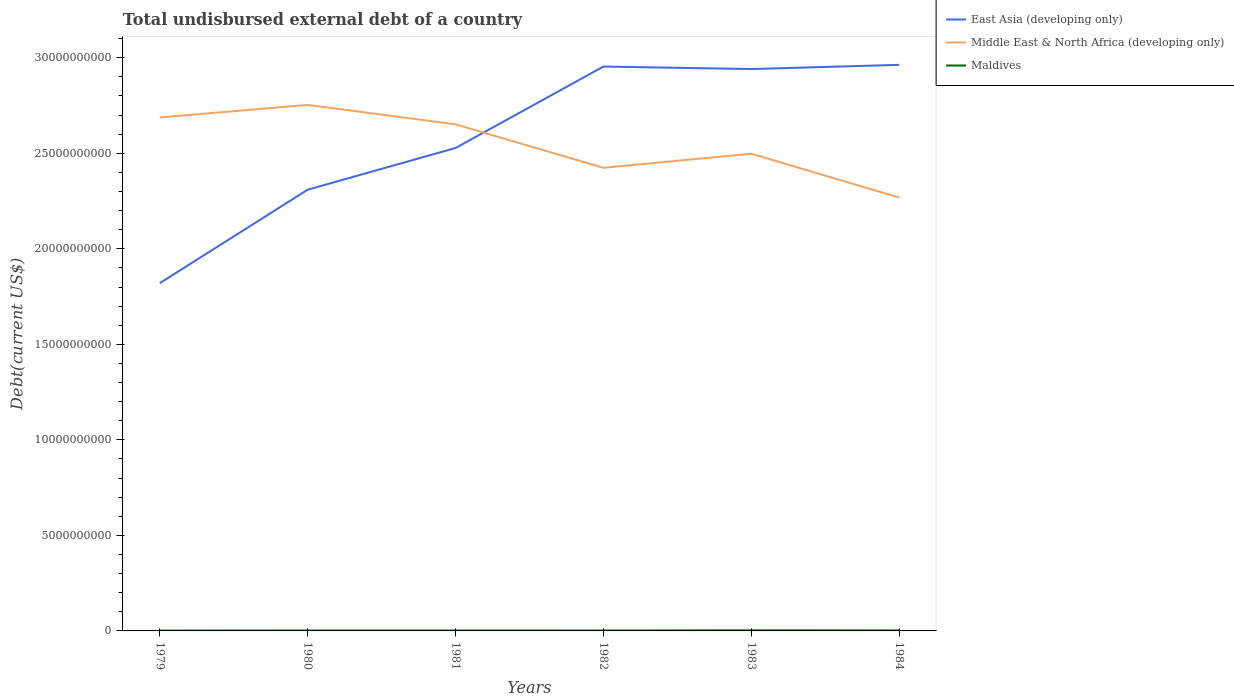Does the line corresponding to East Asia (developing only) intersect with the line corresponding to Middle East & North Africa (developing only)?
Your answer should be compact. Yes. Across all years, what is the maximum total undisbursed external debt in Maldives?
Provide a succinct answer. 1.66e+07. In which year was the total undisbursed external debt in East Asia (developing only) maximum?
Your answer should be very brief. 1979. What is the total total undisbursed external debt in Middle East & North Africa (developing only) in the graph?
Ensure brevity in your answer.  4.85e+09. What is the difference between the highest and the second highest total undisbursed external debt in Maldives?
Offer a terse response. 1.24e+07. Is the total undisbursed external debt in Maldives strictly greater than the total undisbursed external debt in East Asia (developing only) over the years?
Give a very brief answer. Yes. How many lines are there?
Make the answer very short. 3. How many years are there in the graph?
Provide a succinct answer. 6. What is the difference between two consecutive major ticks on the Y-axis?
Provide a short and direct response. 5.00e+09. Where does the legend appear in the graph?
Your answer should be compact. Top right. What is the title of the graph?
Offer a terse response. Total undisbursed external debt of a country. What is the label or title of the X-axis?
Keep it short and to the point. Years. What is the label or title of the Y-axis?
Make the answer very short. Debt(current US$). What is the Debt(current US$) in East Asia (developing only) in 1979?
Ensure brevity in your answer.  1.82e+1. What is the Debt(current US$) of Middle East & North Africa (developing only) in 1979?
Ensure brevity in your answer.  2.69e+1. What is the Debt(current US$) in Maldives in 1979?
Provide a succinct answer. 1.66e+07. What is the Debt(current US$) of East Asia (developing only) in 1980?
Keep it short and to the point. 2.31e+1. What is the Debt(current US$) of Middle East & North Africa (developing only) in 1980?
Provide a succinct answer. 2.75e+1. What is the Debt(current US$) of Maldives in 1980?
Your answer should be compact. 2.10e+07. What is the Debt(current US$) of East Asia (developing only) in 1981?
Your answer should be compact. 2.53e+1. What is the Debt(current US$) of Middle East & North Africa (developing only) in 1981?
Offer a terse response. 2.65e+1. What is the Debt(current US$) of Maldives in 1981?
Ensure brevity in your answer.  2.11e+07. What is the Debt(current US$) in East Asia (developing only) in 1982?
Provide a short and direct response. 2.95e+1. What is the Debt(current US$) in Middle East & North Africa (developing only) in 1982?
Offer a terse response. 2.42e+1. What is the Debt(current US$) of Maldives in 1982?
Keep it short and to the point. 1.96e+07. What is the Debt(current US$) of East Asia (developing only) in 1983?
Your answer should be compact. 2.94e+1. What is the Debt(current US$) of Middle East & North Africa (developing only) in 1983?
Keep it short and to the point. 2.50e+1. What is the Debt(current US$) in Maldives in 1983?
Your response must be concise. 2.91e+07. What is the Debt(current US$) in East Asia (developing only) in 1984?
Keep it short and to the point. 2.96e+1. What is the Debt(current US$) in Middle East & North Africa (developing only) in 1984?
Make the answer very short. 2.27e+1. What is the Debt(current US$) of Maldives in 1984?
Offer a terse response. 2.37e+07. Across all years, what is the maximum Debt(current US$) in East Asia (developing only)?
Offer a very short reply. 2.96e+1. Across all years, what is the maximum Debt(current US$) in Middle East & North Africa (developing only)?
Provide a short and direct response. 2.75e+1. Across all years, what is the maximum Debt(current US$) of Maldives?
Keep it short and to the point. 2.91e+07. Across all years, what is the minimum Debt(current US$) of East Asia (developing only)?
Offer a very short reply. 1.82e+1. Across all years, what is the minimum Debt(current US$) in Middle East & North Africa (developing only)?
Your answer should be very brief. 2.27e+1. Across all years, what is the minimum Debt(current US$) in Maldives?
Provide a succinct answer. 1.66e+07. What is the total Debt(current US$) in East Asia (developing only) in the graph?
Provide a short and direct response. 1.55e+11. What is the total Debt(current US$) in Middle East & North Africa (developing only) in the graph?
Make the answer very short. 1.53e+11. What is the total Debt(current US$) of Maldives in the graph?
Provide a short and direct response. 1.31e+08. What is the difference between the Debt(current US$) of East Asia (developing only) in 1979 and that in 1980?
Make the answer very short. -4.89e+09. What is the difference between the Debt(current US$) in Middle East & North Africa (developing only) in 1979 and that in 1980?
Give a very brief answer. -6.59e+08. What is the difference between the Debt(current US$) in Maldives in 1979 and that in 1980?
Keep it short and to the point. -4.34e+06. What is the difference between the Debt(current US$) in East Asia (developing only) in 1979 and that in 1981?
Your answer should be compact. -7.07e+09. What is the difference between the Debt(current US$) of Middle East & North Africa (developing only) in 1979 and that in 1981?
Keep it short and to the point. 3.59e+08. What is the difference between the Debt(current US$) of Maldives in 1979 and that in 1981?
Your answer should be compact. -4.47e+06. What is the difference between the Debt(current US$) in East Asia (developing only) in 1979 and that in 1982?
Your answer should be compact. -1.13e+1. What is the difference between the Debt(current US$) of Middle East & North Africa (developing only) in 1979 and that in 1982?
Keep it short and to the point. 2.63e+09. What is the difference between the Debt(current US$) of Maldives in 1979 and that in 1982?
Give a very brief answer. -2.97e+06. What is the difference between the Debt(current US$) in East Asia (developing only) in 1979 and that in 1983?
Your answer should be compact. -1.12e+1. What is the difference between the Debt(current US$) of Middle East & North Africa (developing only) in 1979 and that in 1983?
Provide a short and direct response. 1.90e+09. What is the difference between the Debt(current US$) in Maldives in 1979 and that in 1983?
Provide a succinct answer. -1.24e+07. What is the difference between the Debt(current US$) of East Asia (developing only) in 1979 and that in 1984?
Your answer should be very brief. -1.14e+1. What is the difference between the Debt(current US$) of Middle East & North Africa (developing only) in 1979 and that in 1984?
Provide a short and direct response. 4.19e+09. What is the difference between the Debt(current US$) of Maldives in 1979 and that in 1984?
Provide a short and direct response. -7.08e+06. What is the difference between the Debt(current US$) of East Asia (developing only) in 1980 and that in 1981?
Provide a short and direct response. -2.18e+09. What is the difference between the Debt(current US$) in Middle East & North Africa (developing only) in 1980 and that in 1981?
Your answer should be very brief. 1.02e+09. What is the difference between the Debt(current US$) in East Asia (developing only) in 1980 and that in 1982?
Provide a succinct answer. -6.45e+09. What is the difference between the Debt(current US$) in Middle East & North Africa (developing only) in 1980 and that in 1982?
Ensure brevity in your answer.  3.29e+09. What is the difference between the Debt(current US$) in Maldives in 1980 and that in 1982?
Your response must be concise. 1.37e+06. What is the difference between the Debt(current US$) in East Asia (developing only) in 1980 and that in 1983?
Ensure brevity in your answer.  -6.32e+09. What is the difference between the Debt(current US$) of Middle East & North Africa (developing only) in 1980 and that in 1983?
Offer a very short reply. 2.56e+09. What is the difference between the Debt(current US$) in Maldives in 1980 and that in 1983?
Provide a short and direct response. -8.08e+06. What is the difference between the Debt(current US$) in East Asia (developing only) in 1980 and that in 1984?
Provide a short and direct response. -6.53e+09. What is the difference between the Debt(current US$) of Middle East & North Africa (developing only) in 1980 and that in 1984?
Provide a short and direct response. 4.85e+09. What is the difference between the Debt(current US$) in Maldives in 1980 and that in 1984?
Offer a terse response. -2.74e+06. What is the difference between the Debt(current US$) of East Asia (developing only) in 1981 and that in 1982?
Give a very brief answer. -4.26e+09. What is the difference between the Debt(current US$) of Middle East & North Africa (developing only) in 1981 and that in 1982?
Offer a terse response. 2.28e+09. What is the difference between the Debt(current US$) in Maldives in 1981 and that in 1982?
Your answer should be very brief. 1.50e+06. What is the difference between the Debt(current US$) of East Asia (developing only) in 1981 and that in 1983?
Your answer should be compact. -4.13e+09. What is the difference between the Debt(current US$) of Middle East & North Africa (developing only) in 1981 and that in 1983?
Offer a very short reply. 1.54e+09. What is the difference between the Debt(current US$) of Maldives in 1981 and that in 1983?
Your answer should be compact. -7.95e+06. What is the difference between the Debt(current US$) of East Asia (developing only) in 1981 and that in 1984?
Offer a very short reply. -4.35e+09. What is the difference between the Debt(current US$) in Middle East & North Africa (developing only) in 1981 and that in 1984?
Make the answer very short. 3.83e+09. What is the difference between the Debt(current US$) of Maldives in 1981 and that in 1984?
Give a very brief answer. -2.61e+06. What is the difference between the Debt(current US$) in East Asia (developing only) in 1982 and that in 1983?
Your answer should be very brief. 1.31e+08. What is the difference between the Debt(current US$) of Middle East & North Africa (developing only) in 1982 and that in 1983?
Provide a succinct answer. -7.38e+08. What is the difference between the Debt(current US$) of Maldives in 1982 and that in 1983?
Offer a very short reply. -9.46e+06. What is the difference between the Debt(current US$) in East Asia (developing only) in 1982 and that in 1984?
Your response must be concise. -8.84e+07. What is the difference between the Debt(current US$) in Middle East & North Africa (developing only) in 1982 and that in 1984?
Your answer should be compact. 1.56e+09. What is the difference between the Debt(current US$) in Maldives in 1982 and that in 1984?
Your response must be concise. -4.11e+06. What is the difference between the Debt(current US$) in East Asia (developing only) in 1983 and that in 1984?
Make the answer very short. -2.19e+08. What is the difference between the Debt(current US$) in Middle East & North Africa (developing only) in 1983 and that in 1984?
Your answer should be very brief. 2.29e+09. What is the difference between the Debt(current US$) in Maldives in 1983 and that in 1984?
Give a very brief answer. 5.35e+06. What is the difference between the Debt(current US$) in East Asia (developing only) in 1979 and the Debt(current US$) in Middle East & North Africa (developing only) in 1980?
Provide a short and direct response. -9.33e+09. What is the difference between the Debt(current US$) of East Asia (developing only) in 1979 and the Debt(current US$) of Maldives in 1980?
Your answer should be very brief. 1.82e+1. What is the difference between the Debt(current US$) of Middle East & North Africa (developing only) in 1979 and the Debt(current US$) of Maldives in 1980?
Offer a terse response. 2.69e+1. What is the difference between the Debt(current US$) in East Asia (developing only) in 1979 and the Debt(current US$) in Middle East & North Africa (developing only) in 1981?
Your response must be concise. -8.31e+09. What is the difference between the Debt(current US$) in East Asia (developing only) in 1979 and the Debt(current US$) in Maldives in 1981?
Your answer should be very brief. 1.82e+1. What is the difference between the Debt(current US$) in Middle East & North Africa (developing only) in 1979 and the Debt(current US$) in Maldives in 1981?
Offer a terse response. 2.69e+1. What is the difference between the Debt(current US$) in East Asia (developing only) in 1979 and the Debt(current US$) in Middle East & North Africa (developing only) in 1982?
Your answer should be compact. -6.03e+09. What is the difference between the Debt(current US$) of East Asia (developing only) in 1979 and the Debt(current US$) of Maldives in 1982?
Ensure brevity in your answer.  1.82e+1. What is the difference between the Debt(current US$) of Middle East & North Africa (developing only) in 1979 and the Debt(current US$) of Maldives in 1982?
Your answer should be very brief. 2.69e+1. What is the difference between the Debt(current US$) of East Asia (developing only) in 1979 and the Debt(current US$) of Middle East & North Africa (developing only) in 1983?
Your answer should be very brief. -6.77e+09. What is the difference between the Debt(current US$) in East Asia (developing only) in 1979 and the Debt(current US$) in Maldives in 1983?
Make the answer very short. 1.82e+1. What is the difference between the Debt(current US$) of Middle East & North Africa (developing only) in 1979 and the Debt(current US$) of Maldives in 1983?
Offer a terse response. 2.68e+1. What is the difference between the Debt(current US$) of East Asia (developing only) in 1979 and the Debt(current US$) of Middle East & North Africa (developing only) in 1984?
Your answer should be compact. -4.48e+09. What is the difference between the Debt(current US$) in East Asia (developing only) in 1979 and the Debt(current US$) in Maldives in 1984?
Your answer should be very brief. 1.82e+1. What is the difference between the Debt(current US$) in Middle East & North Africa (developing only) in 1979 and the Debt(current US$) in Maldives in 1984?
Your response must be concise. 2.69e+1. What is the difference between the Debt(current US$) of East Asia (developing only) in 1980 and the Debt(current US$) of Middle East & North Africa (developing only) in 1981?
Offer a terse response. -3.42e+09. What is the difference between the Debt(current US$) in East Asia (developing only) in 1980 and the Debt(current US$) in Maldives in 1981?
Give a very brief answer. 2.31e+1. What is the difference between the Debt(current US$) of Middle East & North Africa (developing only) in 1980 and the Debt(current US$) of Maldives in 1981?
Your response must be concise. 2.75e+1. What is the difference between the Debt(current US$) of East Asia (developing only) in 1980 and the Debt(current US$) of Middle East & North Africa (developing only) in 1982?
Offer a terse response. -1.15e+09. What is the difference between the Debt(current US$) of East Asia (developing only) in 1980 and the Debt(current US$) of Maldives in 1982?
Keep it short and to the point. 2.31e+1. What is the difference between the Debt(current US$) of Middle East & North Africa (developing only) in 1980 and the Debt(current US$) of Maldives in 1982?
Provide a short and direct response. 2.75e+1. What is the difference between the Debt(current US$) of East Asia (developing only) in 1980 and the Debt(current US$) of Middle East & North Africa (developing only) in 1983?
Your answer should be very brief. -1.88e+09. What is the difference between the Debt(current US$) in East Asia (developing only) in 1980 and the Debt(current US$) in Maldives in 1983?
Offer a terse response. 2.31e+1. What is the difference between the Debt(current US$) in Middle East & North Africa (developing only) in 1980 and the Debt(current US$) in Maldives in 1983?
Give a very brief answer. 2.75e+1. What is the difference between the Debt(current US$) of East Asia (developing only) in 1980 and the Debt(current US$) of Middle East & North Africa (developing only) in 1984?
Make the answer very short. 4.10e+08. What is the difference between the Debt(current US$) in East Asia (developing only) in 1980 and the Debt(current US$) in Maldives in 1984?
Keep it short and to the point. 2.31e+1. What is the difference between the Debt(current US$) of Middle East & North Africa (developing only) in 1980 and the Debt(current US$) of Maldives in 1984?
Your answer should be very brief. 2.75e+1. What is the difference between the Debt(current US$) of East Asia (developing only) in 1981 and the Debt(current US$) of Middle East & North Africa (developing only) in 1982?
Keep it short and to the point. 1.04e+09. What is the difference between the Debt(current US$) of East Asia (developing only) in 1981 and the Debt(current US$) of Maldives in 1982?
Your answer should be compact. 2.53e+1. What is the difference between the Debt(current US$) of Middle East & North Africa (developing only) in 1981 and the Debt(current US$) of Maldives in 1982?
Your answer should be very brief. 2.65e+1. What is the difference between the Debt(current US$) in East Asia (developing only) in 1981 and the Debt(current US$) in Middle East & North Africa (developing only) in 1983?
Make the answer very short. 3.00e+08. What is the difference between the Debt(current US$) of East Asia (developing only) in 1981 and the Debt(current US$) of Maldives in 1983?
Provide a short and direct response. 2.52e+1. What is the difference between the Debt(current US$) in Middle East & North Africa (developing only) in 1981 and the Debt(current US$) in Maldives in 1983?
Your answer should be very brief. 2.65e+1. What is the difference between the Debt(current US$) of East Asia (developing only) in 1981 and the Debt(current US$) of Middle East & North Africa (developing only) in 1984?
Your response must be concise. 2.59e+09. What is the difference between the Debt(current US$) in East Asia (developing only) in 1981 and the Debt(current US$) in Maldives in 1984?
Your answer should be very brief. 2.53e+1. What is the difference between the Debt(current US$) in Middle East & North Africa (developing only) in 1981 and the Debt(current US$) in Maldives in 1984?
Provide a succinct answer. 2.65e+1. What is the difference between the Debt(current US$) in East Asia (developing only) in 1982 and the Debt(current US$) in Middle East & North Africa (developing only) in 1983?
Offer a terse response. 4.56e+09. What is the difference between the Debt(current US$) of East Asia (developing only) in 1982 and the Debt(current US$) of Maldives in 1983?
Offer a very short reply. 2.95e+1. What is the difference between the Debt(current US$) of Middle East & North Africa (developing only) in 1982 and the Debt(current US$) of Maldives in 1983?
Your answer should be very brief. 2.42e+1. What is the difference between the Debt(current US$) of East Asia (developing only) in 1982 and the Debt(current US$) of Middle East & North Africa (developing only) in 1984?
Provide a succinct answer. 6.86e+09. What is the difference between the Debt(current US$) of East Asia (developing only) in 1982 and the Debt(current US$) of Maldives in 1984?
Your response must be concise. 2.95e+1. What is the difference between the Debt(current US$) in Middle East & North Africa (developing only) in 1982 and the Debt(current US$) in Maldives in 1984?
Your response must be concise. 2.42e+1. What is the difference between the Debt(current US$) in East Asia (developing only) in 1983 and the Debt(current US$) in Middle East & North Africa (developing only) in 1984?
Offer a very short reply. 6.73e+09. What is the difference between the Debt(current US$) of East Asia (developing only) in 1983 and the Debt(current US$) of Maldives in 1984?
Offer a terse response. 2.94e+1. What is the difference between the Debt(current US$) in Middle East & North Africa (developing only) in 1983 and the Debt(current US$) in Maldives in 1984?
Offer a very short reply. 2.50e+1. What is the average Debt(current US$) of East Asia (developing only) per year?
Offer a very short reply. 2.59e+1. What is the average Debt(current US$) of Middle East & North Africa (developing only) per year?
Your answer should be very brief. 2.55e+1. What is the average Debt(current US$) of Maldives per year?
Offer a very short reply. 2.19e+07. In the year 1979, what is the difference between the Debt(current US$) in East Asia (developing only) and Debt(current US$) in Middle East & North Africa (developing only)?
Give a very brief answer. -8.67e+09. In the year 1979, what is the difference between the Debt(current US$) of East Asia (developing only) and Debt(current US$) of Maldives?
Keep it short and to the point. 1.82e+1. In the year 1979, what is the difference between the Debt(current US$) in Middle East & North Africa (developing only) and Debt(current US$) in Maldives?
Provide a short and direct response. 2.69e+1. In the year 1980, what is the difference between the Debt(current US$) of East Asia (developing only) and Debt(current US$) of Middle East & North Africa (developing only)?
Make the answer very short. -4.44e+09. In the year 1980, what is the difference between the Debt(current US$) of East Asia (developing only) and Debt(current US$) of Maldives?
Give a very brief answer. 2.31e+1. In the year 1980, what is the difference between the Debt(current US$) of Middle East & North Africa (developing only) and Debt(current US$) of Maldives?
Your response must be concise. 2.75e+1. In the year 1981, what is the difference between the Debt(current US$) in East Asia (developing only) and Debt(current US$) in Middle East & North Africa (developing only)?
Provide a short and direct response. -1.24e+09. In the year 1981, what is the difference between the Debt(current US$) of East Asia (developing only) and Debt(current US$) of Maldives?
Offer a terse response. 2.53e+1. In the year 1981, what is the difference between the Debt(current US$) in Middle East & North Africa (developing only) and Debt(current US$) in Maldives?
Offer a terse response. 2.65e+1. In the year 1982, what is the difference between the Debt(current US$) of East Asia (developing only) and Debt(current US$) of Middle East & North Africa (developing only)?
Ensure brevity in your answer.  5.30e+09. In the year 1982, what is the difference between the Debt(current US$) in East Asia (developing only) and Debt(current US$) in Maldives?
Provide a succinct answer. 2.95e+1. In the year 1982, what is the difference between the Debt(current US$) in Middle East & North Africa (developing only) and Debt(current US$) in Maldives?
Provide a short and direct response. 2.42e+1. In the year 1983, what is the difference between the Debt(current US$) of East Asia (developing only) and Debt(current US$) of Middle East & North Africa (developing only)?
Your answer should be compact. 4.43e+09. In the year 1983, what is the difference between the Debt(current US$) of East Asia (developing only) and Debt(current US$) of Maldives?
Provide a succinct answer. 2.94e+1. In the year 1983, what is the difference between the Debt(current US$) of Middle East & North Africa (developing only) and Debt(current US$) of Maldives?
Your answer should be very brief. 2.49e+1. In the year 1984, what is the difference between the Debt(current US$) in East Asia (developing only) and Debt(current US$) in Middle East & North Africa (developing only)?
Ensure brevity in your answer.  6.94e+09. In the year 1984, what is the difference between the Debt(current US$) of East Asia (developing only) and Debt(current US$) of Maldives?
Keep it short and to the point. 2.96e+1. In the year 1984, what is the difference between the Debt(current US$) in Middle East & North Africa (developing only) and Debt(current US$) in Maldives?
Your answer should be compact. 2.27e+1. What is the ratio of the Debt(current US$) of East Asia (developing only) in 1979 to that in 1980?
Give a very brief answer. 0.79. What is the ratio of the Debt(current US$) in Middle East & North Africa (developing only) in 1979 to that in 1980?
Keep it short and to the point. 0.98. What is the ratio of the Debt(current US$) of Maldives in 1979 to that in 1980?
Offer a terse response. 0.79. What is the ratio of the Debt(current US$) of East Asia (developing only) in 1979 to that in 1981?
Provide a short and direct response. 0.72. What is the ratio of the Debt(current US$) of Middle East & North Africa (developing only) in 1979 to that in 1981?
Provide a short and direct response. 1.01. What is the ratio of the Debt(current US$) of Maldives in 1979 to that in 1981?
Your answer should be compact. 0.79. What is the ratio of the Debt(current US$) of East Asia (developing only) in 1979 to that in 1982?
Make the answer very short. 0.62. What is the ratio of the Debt(current US$) of Middle East & North Africa (developing only) in 1979 to that in 1982?
Your answer should be very brief. 1.11. What is the ratio of the Debt(current US$) in Maldives in 1979 to that in 1982?
Offer a terse response. 0.85. What is the ratio of the Debt(current US$) of East Asia (developing only) in 1979 to that in 1983?
Offer a terse response. 0.62. What is the ratio of the Debt(current US$) of Middle East & North Africa (developing only) in 1979 to that in 1983?
Provide a short and direct response. 1.08. What is the ratio of the Debt(current US$) of Maldives in 1979 to that in 1983?
Offer a terse response. 0.57. What is the ratio of the Debt(current US$) in East Asia (developing only) in 1979 to that in 1984?
Offer a very short reply. 0.61. What is the ratio of the Debt(current US$) of Middle East & North Africa (developing only) in 1979 to that in 1984?
Offer a very short reply. 1.18. What is the ratio of the Debt(current US$) of Maldives in 1979 to that in 1984?
Make the answer very short. 0.7. What is the ratio of the Debt(current US$) of East Asia (developing only) in 1980 to that in 1981?
Keep it short and to the point. 0.91. What is the ratio of the Debt(current US$) of Middle East & North Africa (developing only) in 1980 to that in 1981?
Make the answer very short. 1.04. What is the ratio of the Debt(current US$) of Maldives in 1980 to that in 1981?
Your answer should be compact. 0.99. What is the ratio of the Debt(current US$) in East Asia (developing only) in 1980 to that in 1982?
Give a very brief answer. 0.78. What is the ratio of the Debt(current US$) of Middle East & North Africa (developing only) in 1980 to that in 1982?
Offer a terse response. 1.14. What is the ratio of the Debt(current US$) in Maldives in 1980 to that in 1982?
Give a very brief answer. 1.07. What is the ratio of the Debt(current US$) of East Asia (developing only) in 1980 to that in 1983?
Your answer should be compact. 0.79. What is the ratio of the Debt(current US$) in Middle East & North Africa (developing only) in 1980 to that in 1983?
Your answer should be very brief. 1.1. What is the ratio of the Debt(current US$) of Maldives in 1980 to that in 1983?
Your response must be concise. 0.72. What is the ratio of the Debt(current US$) in East Asia (developing only) in 1980 to that in 1984?
Keep it short and to the point. 0.78. What is the ratio of the Debt(current US$) in Middle East & North Africa (developing only) in 1980 to that in 1984?
Provide a succinct answer. 1.21. What is the ratio of the Debt(current US$) of Maldives in 1980 to that in 1984?
Your answer should be compact. 0.88. What is the ratio of the Debt(current US$) in East Asia (developing only) in 1981 to that in 1982?
Keep it short and to the point. 0.86. What is the ratio of the Debt(current US$) of Middle East & North Africa (developing only) in 1981 to that in 1982?
Make the answer very short. 1.09. What is the ratio of the Debt(current US$) of Maldives in 1981 to that in 1982?
Your answer should be compact. 1.08. What is the ratio of the Debt(current US$) of East Asia (developing only) in 1981 to that in 1983?
Your response must be concise. 0.86. What is the ratio of the Debt(current US$) of Middle East & North Africa (developing only) in 1981 to that in 1983?
Keep it short and to the point. 1.06. What is the ratio of the Debt(current US$) of Maldives in 1981 to that in 1983?
Offer a very short reply. 0.73. What is the ratio of the Debt(current US$) of East Asia (developing only) in 1981 to that in 1984?
Your response must be concise. 0.85. What is the ratio of the Debt(current US$) of Middle East & North Africa (developing only) in 1981 to that in 1984?
Offer a very short reply. 1.17. What is the ratio of the Debt(current US$) in Maldives in 1981 to that in 1984?
Offer a very short reply. 0.89. What is the ratio of the Debt(current US$) of East Asia (developing only) in 1982 to that in 1983?
Keep it short and to the point. 1. What is the ratio of the Debt(current US$) of Middle East & North Africa (developing only) in 1982 to that in 1983?
Provide a short and direct response. 0.97. What is the ratio of the Debt(current US$) in Maldives in 1982 to that in 1983?
Ensure brevity in your answer.  0.67. What is the ratio of the Debt(current US$) in East Asia (developing only) in 1982 to that in 1984?
Make the answer very short. 1. What is the ratio of the Debt(current US$) in Middle East & North Africa (developing only) in 1982 to that in 1984?
Offer a very short reply. 1.07. What is the ratio of the Debt(current US$) of Maldives in 1982 to that in 1984?
Make the answer very short. 0.83. What is the ratio of the Debt(current US$) in Middle East & North Africa (developing only) in 1983 to that in 1984?
Your answer should be very brief. 1.1. What is the ratio of the Debt(current US$) in Maldives in 1983 to that in 1984?
Make the answer very short. 1.23. What is the difference between the highest and the second highest Debt(current US$) in East Asia (developing only)?
Your response must be concise. 8.84e+07. What is the difference between the highest and the second highest Debt(current US$) in Middle East & North Africa (developing only)?
Offer a very short reply. 6.59e+08. What is the difference between the highest and the second highest Debt(current US$) in Maldives?
Ensure brevity in your answer.  5.35e+06. What is the difference between the highest and the lowest Debt(current US$) of East Asia (developing only)?
Keep it short and to the point. 1.14e+1. What is the difference between the highest and the lowest Debt(current US$) in Middle East & North Africa (developing only)?
Keep it short and to the point. 4.85e+09. What is the difference between the highest and the lowest Debt(current US$) of Maldives?
Your answer should be compact. 1.24e+07. 